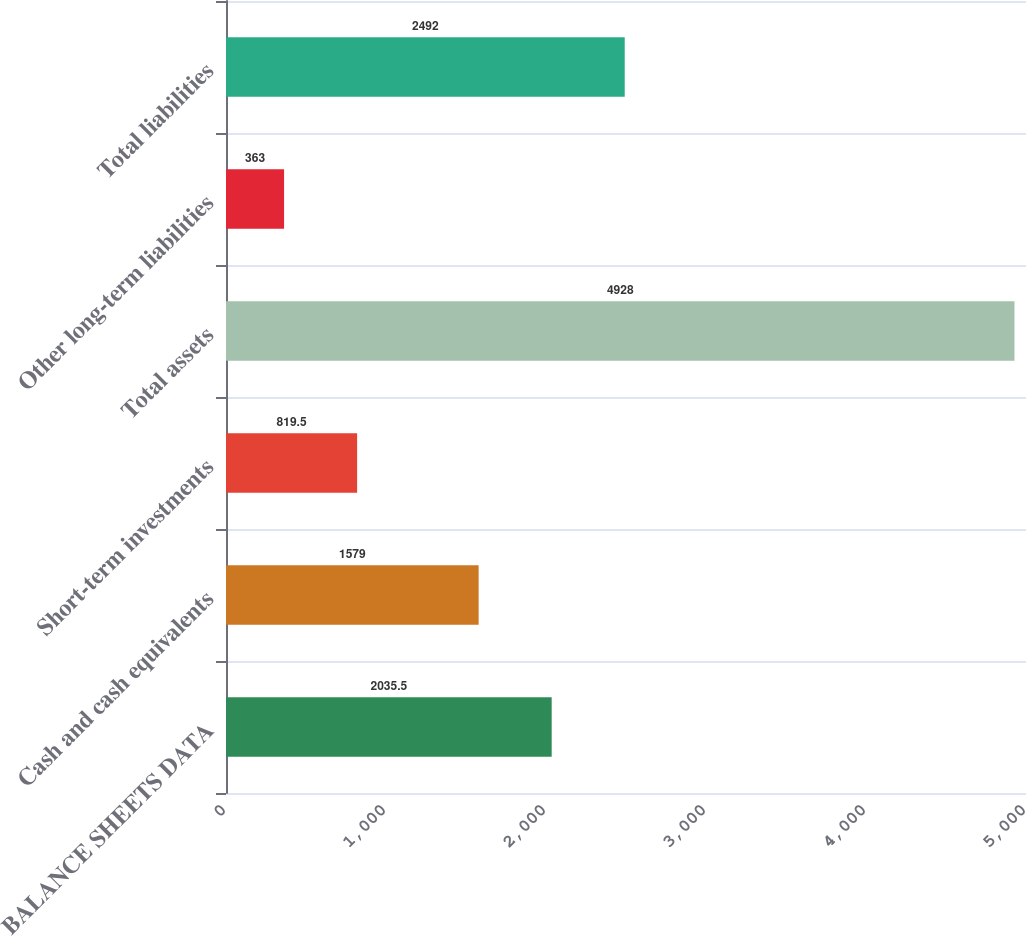Convert chart to OTSL. <chart><loc_0><loc_0><loc_500><loc_500><bar_chart><fcel>BALANCE SHEETS DATA<fcel>Cash and cash equivalents<fcel>Short-term investments<fcel>Total assets<fcel>Other long-term liabilities<fcel>Total liabilities<nl><fcel>2035.5<fcel>1579<fcel>819.5<fcel>4928<fcel>363<fcel>2492<nl></chart> 